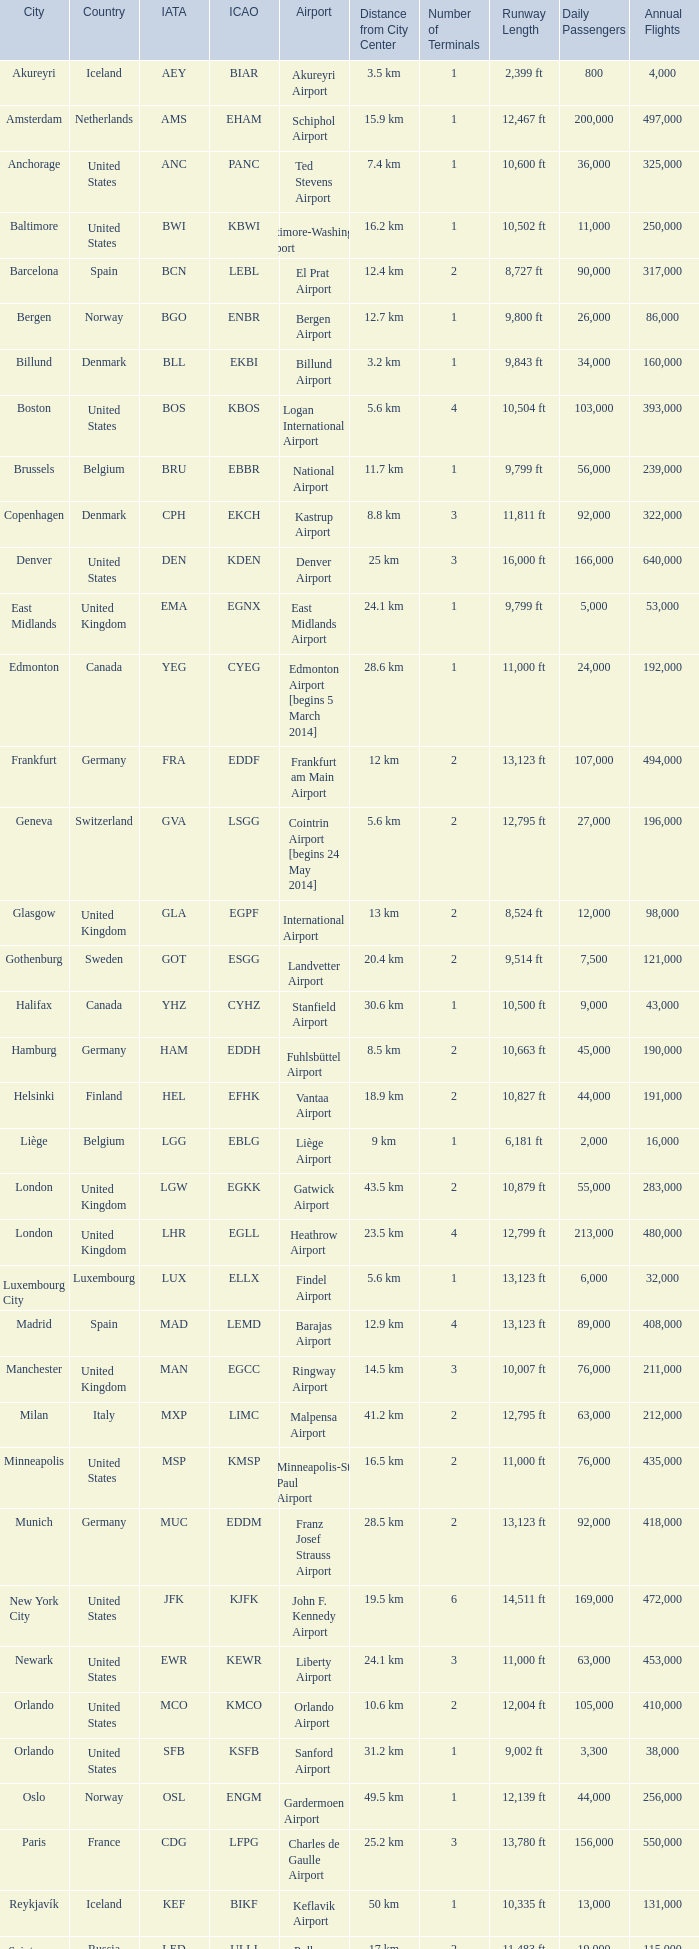What is the Airport with a ICAO of EDDH? Fuhlsbüttel Airport. 